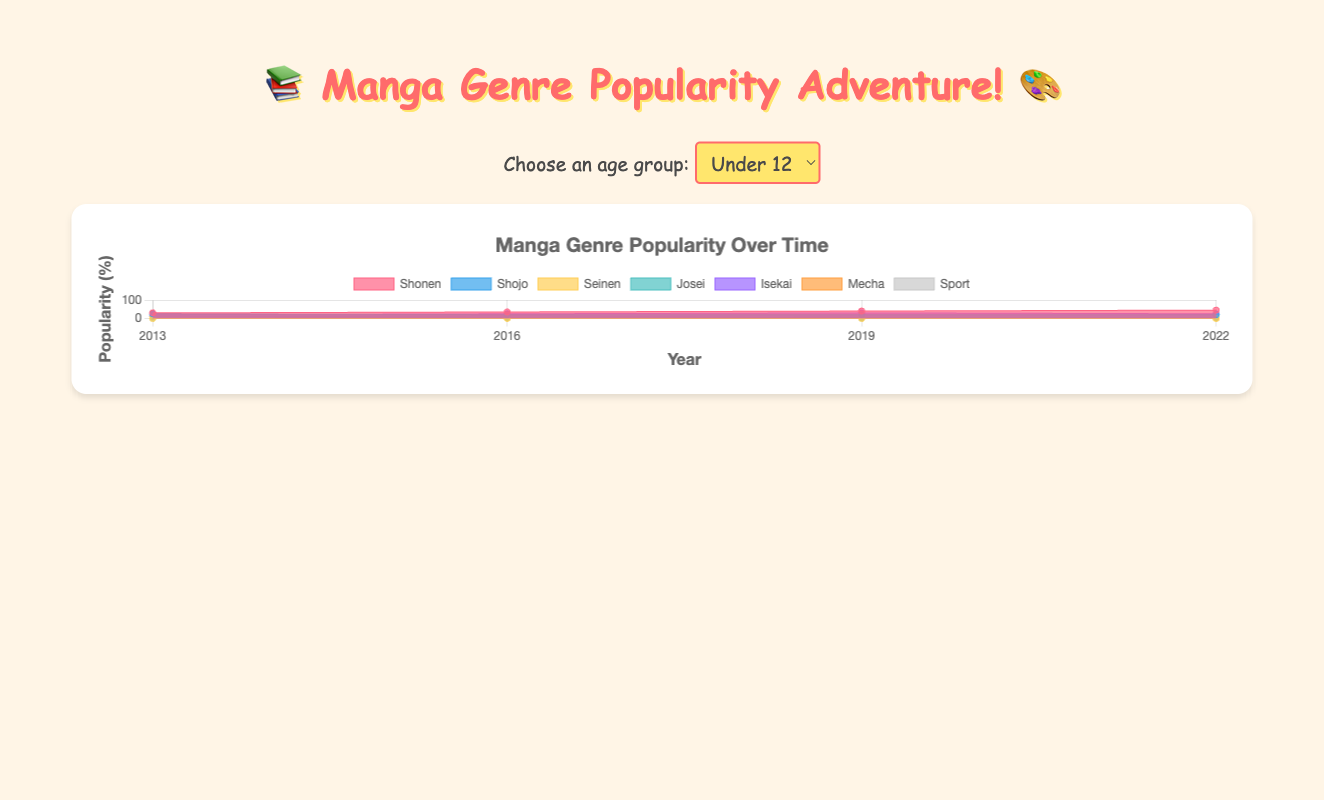What's the title of the figure? The visual element at the top center of the chart displays the title. It reads: "Manga Genre Popularity Over Time"
Answer: Manga Genre Popularity Over Time Which genre is the most popular among the under-12 age group in 2022? Looking at the plotted areas for the under-12 age group in 2022, the highest value is for shonen, which has the largest area.
Answer: Shonen How has the popularity of isekai changed among the 12-18 age group from 2013 to 2022? Examine the area corresponding to isekai for the 12-18 age group across different years. In 2013, isekai had lower values compared to 2022 where it increased to a significant value. This indicates a rise in popularity.
Answer: Increased For the 18-24 age group, what is the total percentage covered by seinen and josei genres in 2022? For 2022, the values for seinen and josei in the 18-24 age group are 30% and 20% respectively. Summing these gives: 30 + 20 = 50
Answer: 50% Which age group saw the largest increase in popularity for shonen from 2013 to 2022? Assess the difference in shonen values from 2013 to 2022 across all age groups. For under 12, it increases from 30 to 45; for 12-18, it drops from 40 to 30; for 18-24, it decreases from 35 to 20; for 24-30, it drops from 30 to 15. The largest increase is among the under-12s with an increase of 15.
Answer: Under 12 How did the popularity of sports manga change for the age group under 12 from 2013 to 2022? By analyzing the plot, sports manga starts at 15% popularity in 2013 and decreases to 5% in 2022 among the under-12 age group. This shows a decline.
Answer: Decreased Which year had the highest overall popularity for shojo manga across all age groups? Add the values for shojo manga across all age groups for each year. The sum for shojo in 2022 beats the other years as it has consistently high values in both the 12-18 and under 12 groups, making it the highest overall.
Answer: 2022 What was the trend for mecha genre among 24-30 age group from 2013 to 2022? Reviewing the areas for mecha for the 24-30 age group, the popularity value remained constant at 5% each year from 2013 to 2022 indicating no change in trend.
Answer: Constant Compare the popularity of shojo and sport genres for the 12-18 age group in 2016. Which one is more popular and by how much? For 2016, shojo has a popularity value of 25%, whereas sport has only 5%. The difference is calculated as 25 - 5 = 20, indicating shojo is more popular by 20%.
Answer: Shojo by 20% Which genre showed consistent growth in popularity among the under-12 age group over the years and how can you describe this trend? Considering each genre, for under 12, shonen shows a consistent increase from 30% in 2013 to 45% in 2022. Describe this as a steady upward trend.
Answer: Shonen consistently grew 